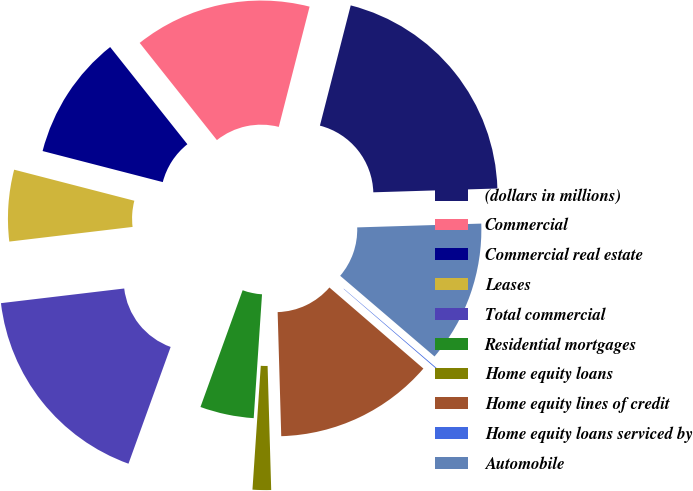Convert chart to OTSL. <chart><loc_0><loc_0><loc_500><loc_500><pie_chart><fcel>(dollars in millions)<fcel>Commercial<fcel>Commercial real estate<fcel>Leases<fcel>Total commercial<fcel>Residential mortgages<fcel>Home equity loans<fcel>Home equity lines of credit<fcel>Home equity loans serviced by<fcel>Automobile<nl><fcel>20.52%<fcel>14.68%<fcel>10.29%<fcel>5.91%<fcel>17.6%<fcel>4.45%<fcel>1.53%<fcel>13.21%<fcel>0.07%<fcel>11.75%<nl></chart> 